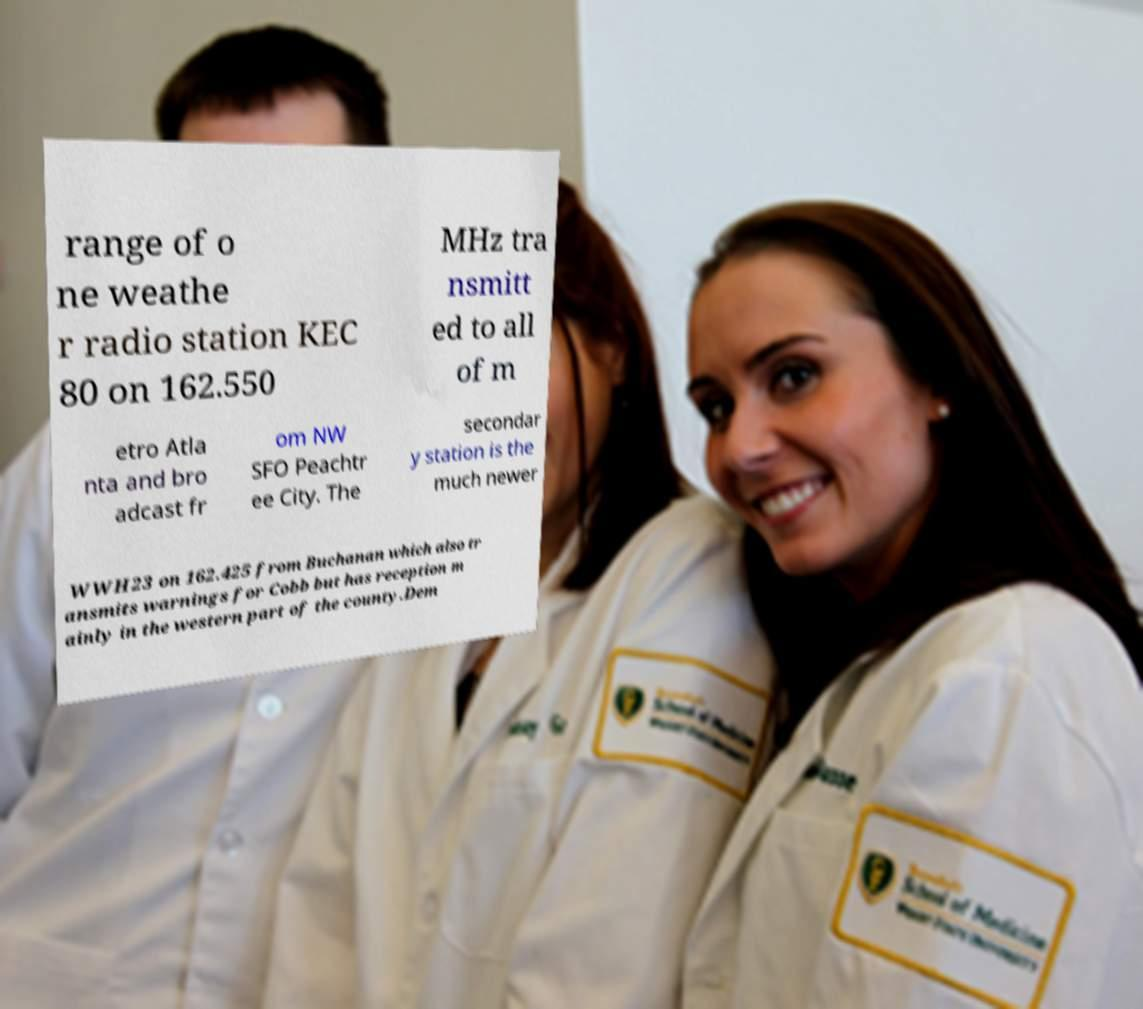For documentation purposes, I need the text within this image transcribed. Could you provide that? range of o ne weathe r radio station KEC 80 on 162.550 MHz tra nsmitt ed to all of m etro Atla nta and bro adcast fr om NW SFO Peachtr ee City. The secondar y station is the much newer WWH23 on 162.425 from Buchanan which also tr ansmits warnings for Cobb but has reception m ainly in the western part of the county.Dem 